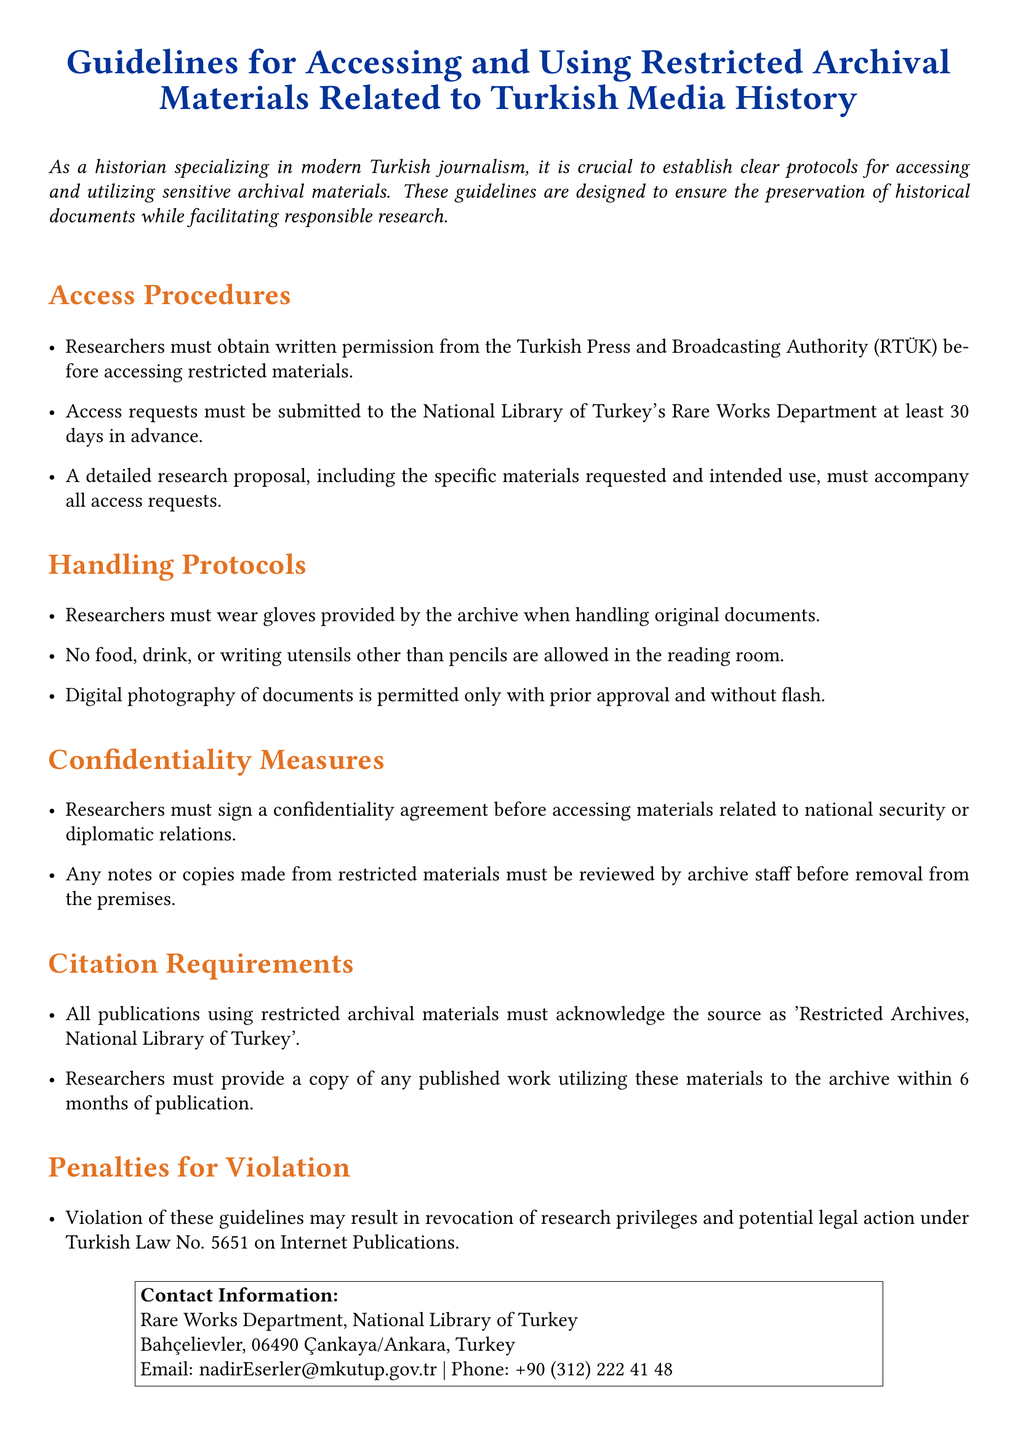What is the organization that researchers must obtain written permission from? The document specifies that researchers must obtain permission from the Turkish Press and Broadcasting Authority (RTÜK).
Answer: Turkish Press and Broadcasting Authority (RTÜK) How many days in advance must access requests be submitted? The document states that access requests must be submitted at least 30 days in advance.
Answer: 30 days What must accompany all access requests? A detailed research proposal, including specific materials requested and intended use, must accompany all access requests.
Answer: A detailed research proposal What type of agreement must researchers sign before accessing certain materials? Researchers must sign a confidentiality agreement before accessing materials related to national security or diplomatic relations.
Answer: Confidentiality agreement What is required for publications using restricted archival materials? The document requires all publications using restricted archival materials to acknowledge the source.
Answer: Acknowledge the source What may result from violating these guidelines? The document states that violation of guidelines may result in revocation of research privileges and potential legal action.
Answer: Revocation of research privileges What materials are researchers prohibited from bringing to the reading room? The document lists that food, drink, or writing utensils other than pencils are not allowed.
Answer: Food, drink, or writing utensils What department should access requests be submitted to? The document indicates that access requests should be submitted to the National Library of Turkey's Rare Works Department.
Answer: Rare Works Department How soon must a copy of published work utilizing restricted materials be provided to the archive? Researchers must provide a copy of any published work within 6 months of publication.
Answer: 6 months 